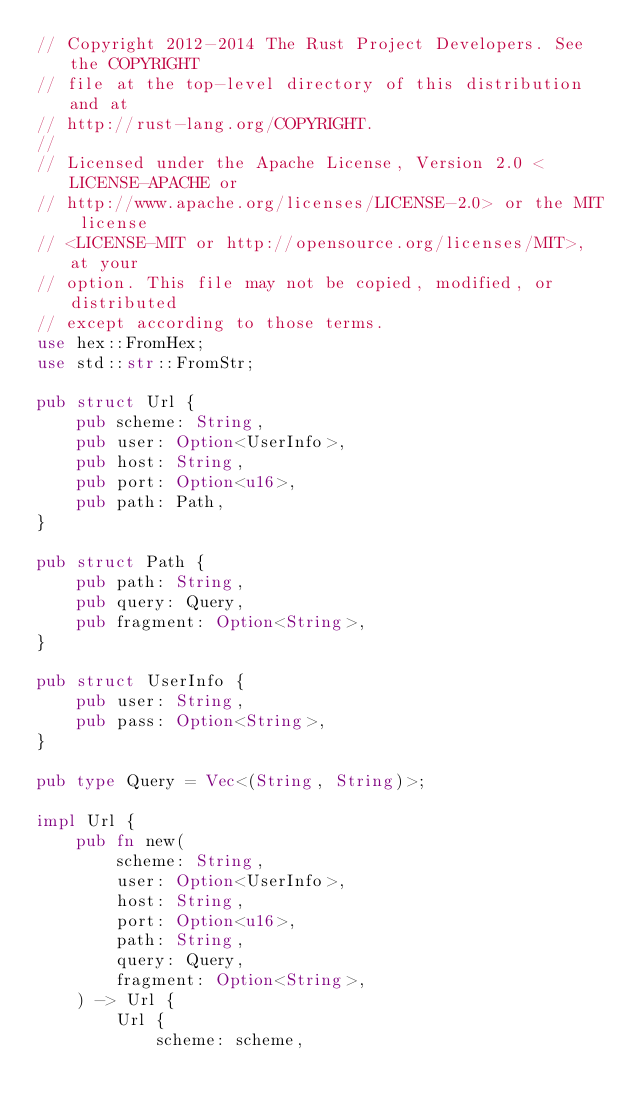Convert code to text. <code><loc_0><loc_0><loc_500><loc_500><_Rust_>// Copyright 2012-2014 The Rust Project Developers. See the COPYRIGHT
// file at the top-level directory of this distribution and at
// http://rust-lang.org/COPYRIGHT.
//
// Licensed under the Apache License, Version 2.0 <LICENSE-APACHE or
// http://www.apache.org/licenses/LICENSE-2.0> or the MIT license
// <LICENSE-MIT or http://opensource.org/licenses/MIT>, at your
// option. This file may not be copied, modified, or distributed
// except according to those terms.
use hex::FromHex;
use std::str::FromStr;

pub struct Url {
    pub scheme: String,
    pub user: Option<UserInfo>,
    pub host: String,
    pub port: Option<u16>,
    pub path: Path,
}

pub struct Path {
    pub path: String,
    pub query: Query,
    pub fragment: Option<String>,
}

pub struct UserInfo {
    pub user: String,
    pub pass: Option<String>,
}

pub type Query = Vec<(String, String)>;

impl Url {
    pub fn new(
        scheme: String,
        user: Option<UserInfo>,
        host: String,
        port: Option<u16>,
        path: String,
        query: Query,
        fragment: Option<String>,
    ) -> Url {
        Url {
            scheme: scheme,</code> 